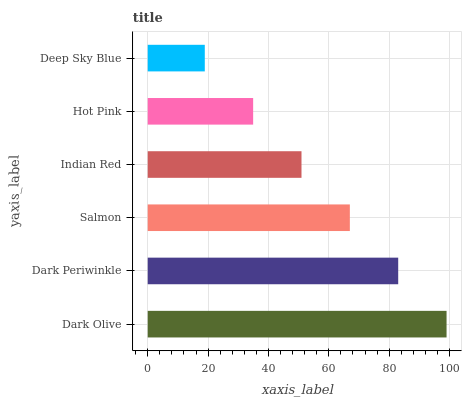Is Deep Sky Blue the minimum?
Answer yes or no. Yes. Is Dark Olive the maximum?
Answer yes or no. Yes. Is Dark Periwinkle the minimum?
Answer yes or no. No. Is Dark Periwinkle the maximum?
Answer yes or no. No. Is Dark Olive greater than Dark Periwinkle?
Answer yes or no. Yes. Is Dark Periwinkle less than Dark Olive?
Answer yes or no. Yes. Is Dark Periwinkle greater than Dark Olive?
Answer yes or no. No. Is Dark Olive less than Dark Periwinkle?
Answer yes or no. No. Is Salmon the high median?
Answer yes or no. Yes. Is Indian Red the low median?
Answer yes or no. Yes. Is Indian Red the high median?
Answer yes or no. No. Is Dark Olive the low median?
Answer yes or no. No. 